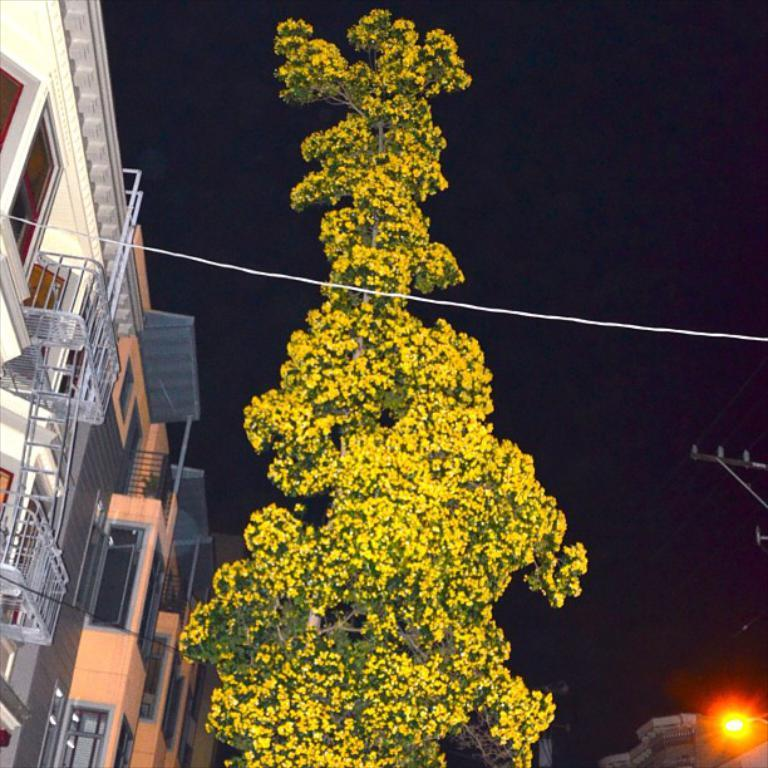What is the main subject in the center of the image? There is a tree in the center of the image. What structures can be seen on the left side of the image? There are buildings on the left side of the image. What is located on the right side of the image? There is a light on the right side of the image. What can be seen in the background of the image? The sky is visible in the background of the image, and there is also a wire present. What type of haircut does the tree have in the image? The tree does not have a haircut, as it is a natural object and not a person. 